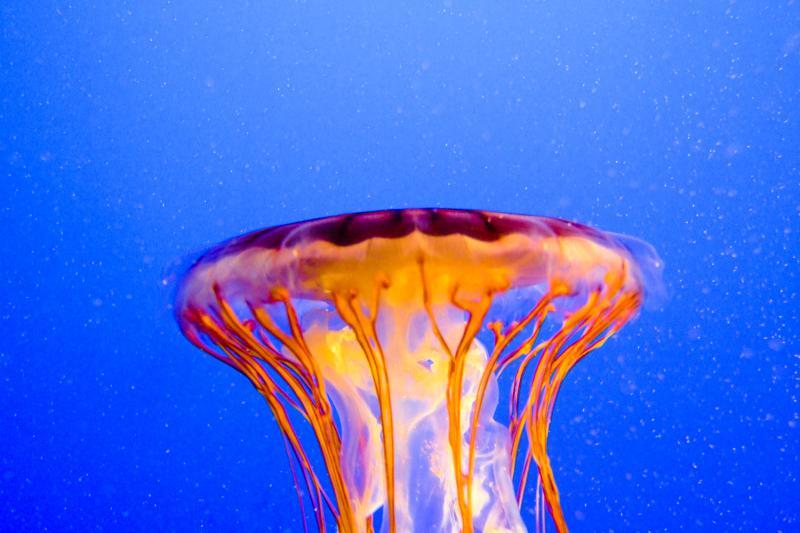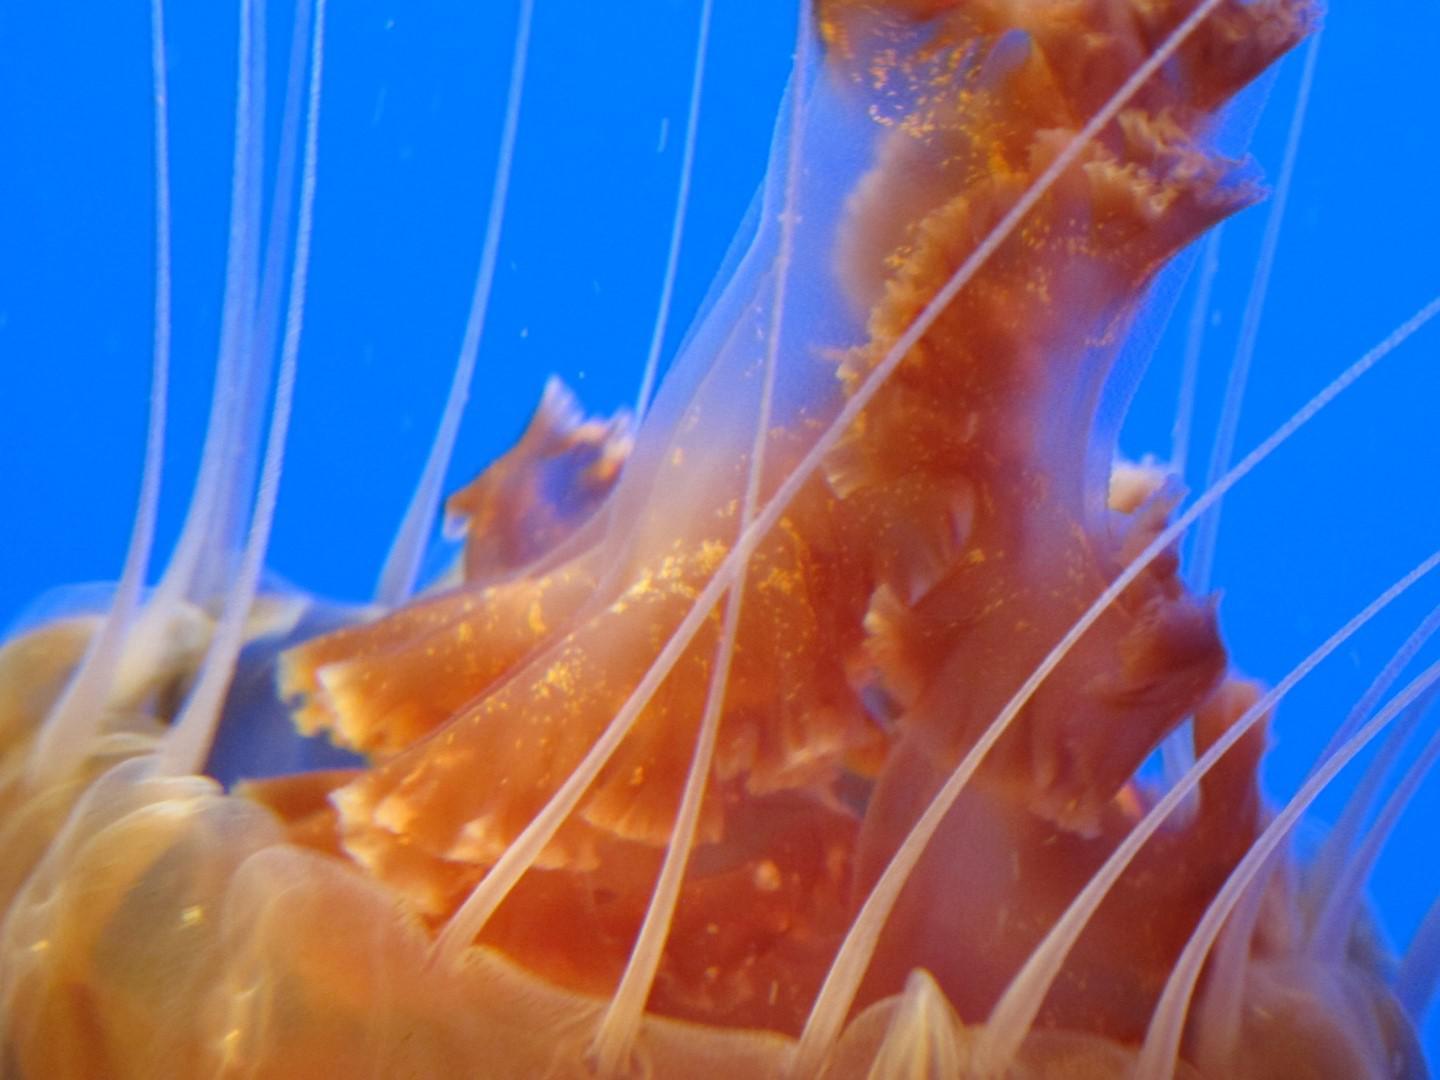The first image is the image on the left, the second image is the image on the right. Given the left and right images, does the statement "Each image contains one jellyfish with an orange 'cap', and the lefthand jellyfish has an upright 'cap' with tentacles trailing downward." hold true? Answer yes or no. Yes. The first image is the image on the left, the second image is the image on the right. Analyze the images presented: Is the assertion "One of the jellyfish is heading in a horizontal direction." valid? Answer yes or no. No. 